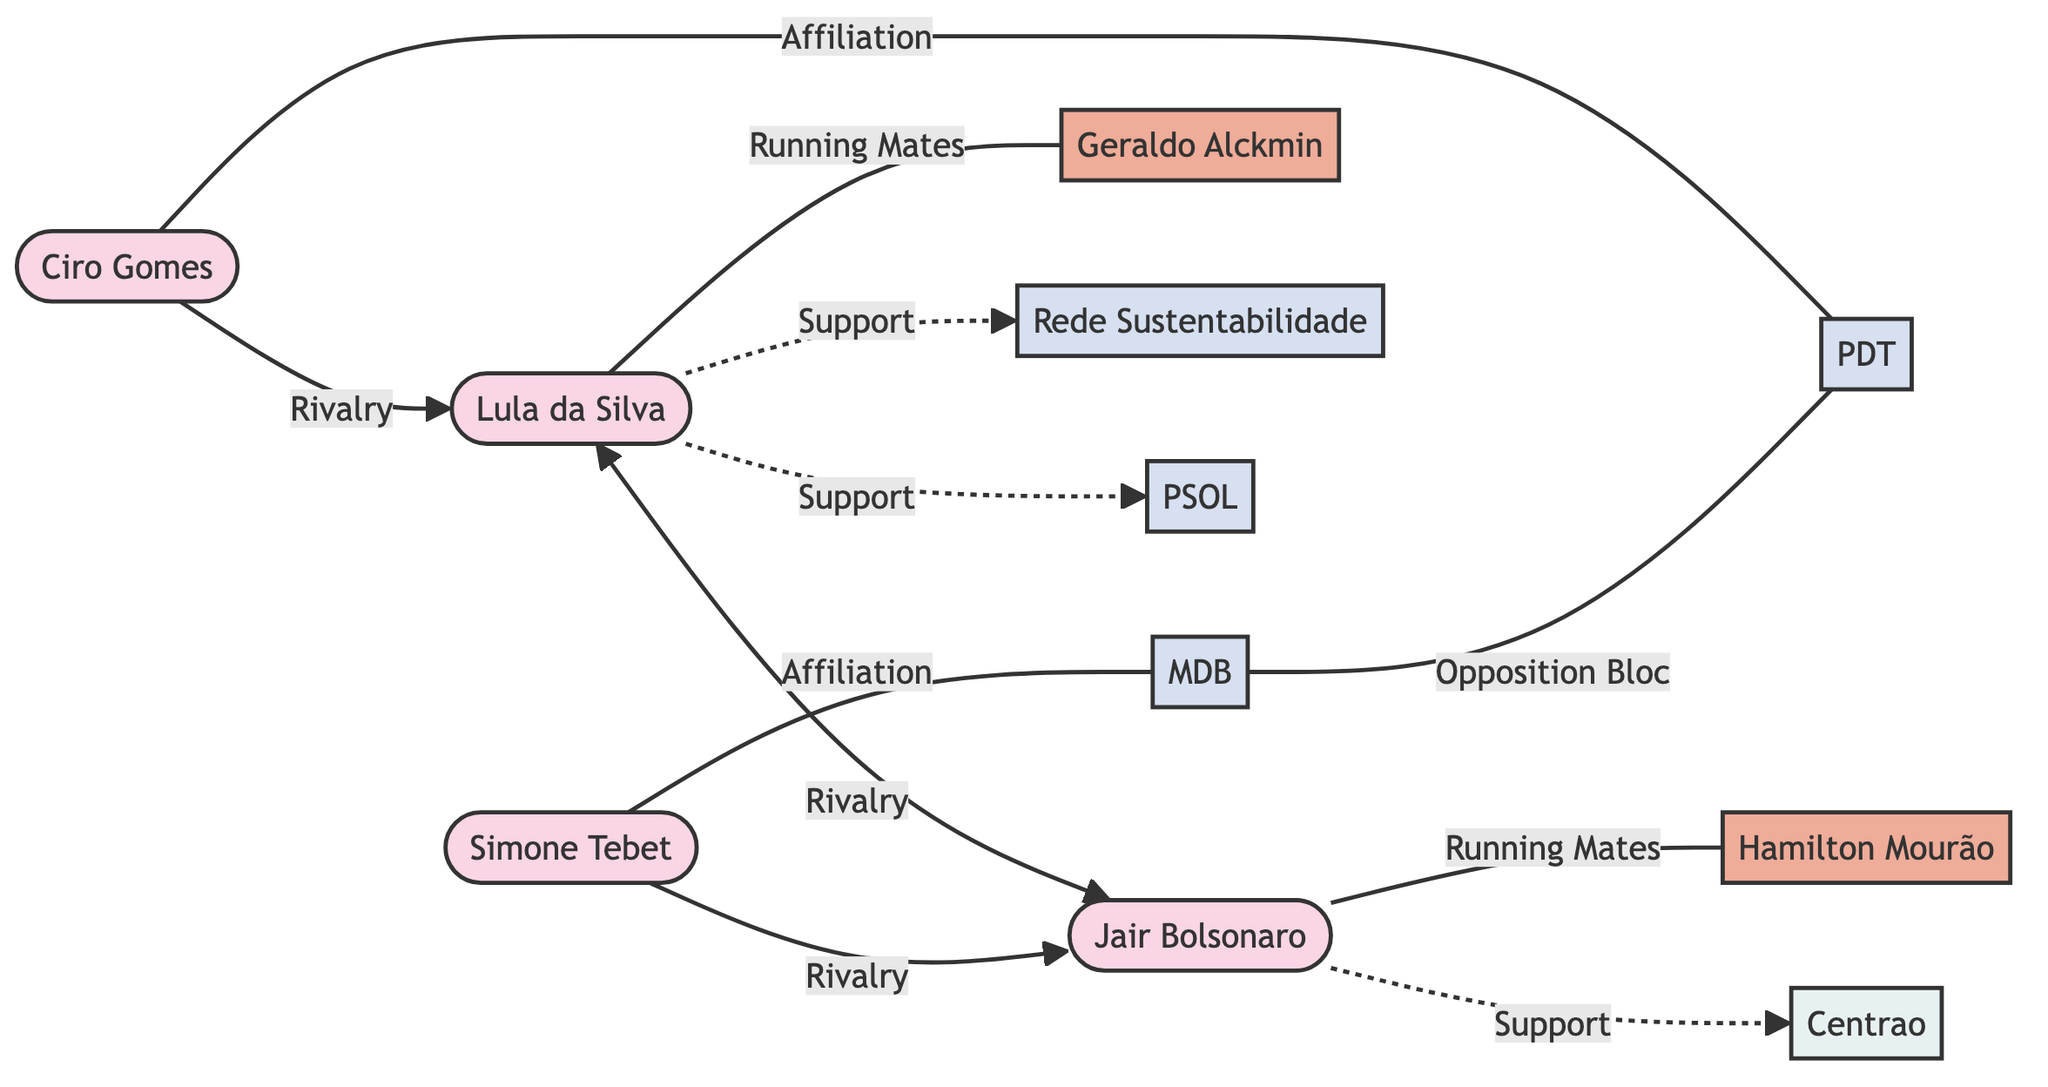What is the total number of candidates represented in the diagram? The diagram identifies four presidential candidates: Lula da Silva, Jair Bolsonaro, Simone Tebet, and Ciro Gomes. Therefore, we count the distinct candidate nodes to reach the total.
Answer: 4 Who is the running mate of Lula da Silva? According to the diagram, the connection labeled "Running Mates" links Lula da Silva with Geraldo Alckmin, indicating that Alckmin is partnered with Lula.
Answer: Geraldo Alckmin What relationships exist between Jair Bolsonaro and Ciro Gomes? The diagram shows no direct relationship between Jair Bolsonaro and Ciro Gomes. However, both have a "Rivalry" connection with different candidates, indicating indirect competition. The edge relationship between them is absent.
Answer: None Which political bloc supports Jair Bolsonaro? The diagram indicates a support relationship from Jair Bolsonaro to Centrao, which is defined as a political bloc. Therefore, Centrao is the answer since it directly supports Bolsonaro.
Answer: Centrao How many supporting parties are linked to Lula da Silva? The diagram depicts two support relationships for Lula da Silva: one with Rede Sustentabilidade and another with PSOL, leading to the conclusion that there are two supporting parties.
Answer: 2 What type of relationship exists between Simone Tebet and the MDB? In the diagram, a solid line labeled "Affiliation" connects Simone Tebet to the MDB, indicating that Tebet is affiliated with this party, defining the nature of their relationship.
Answer: Affiliation How do Ciro Gomes and Lula da Silva relate to each other in the context of the diagram? The diagram shows a rivalry relationship connecting Ciro Gomes and Lula da Silva. This indicates that they compete against each other in the election context, establishing their relationship type.
Answer: Rivalry Which candidate shares a running mate with Hamilton Mourão? The diagram links Hamilton Mourão to Jair Bolsonaro through a "Running Mates" relationship, meaning that Bolsonaro is Mourão's running mate. Thus, Mourão and Bolsonaro are connected in this way.
Answer: Jair Bolsonaro What is the total number of edges in the diagram? By counting the connections (edges) depicted in the diagram, we identify a total of ten relationships, confirming the count of edges to reach the total number.
Answer: 10 